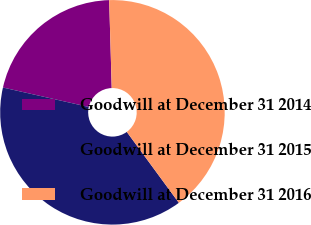<chart> <loc_0><loc_0><loc_500><loc_500><pie_chart><fcel>Goodwill at December 31 2014<fcel>Goodwill at December 31 2015<fcel>Goodwill at December 31 2016<nl><fcel>20.99%<fcel>38.62%<fcel>40.38%<nl></chart> 